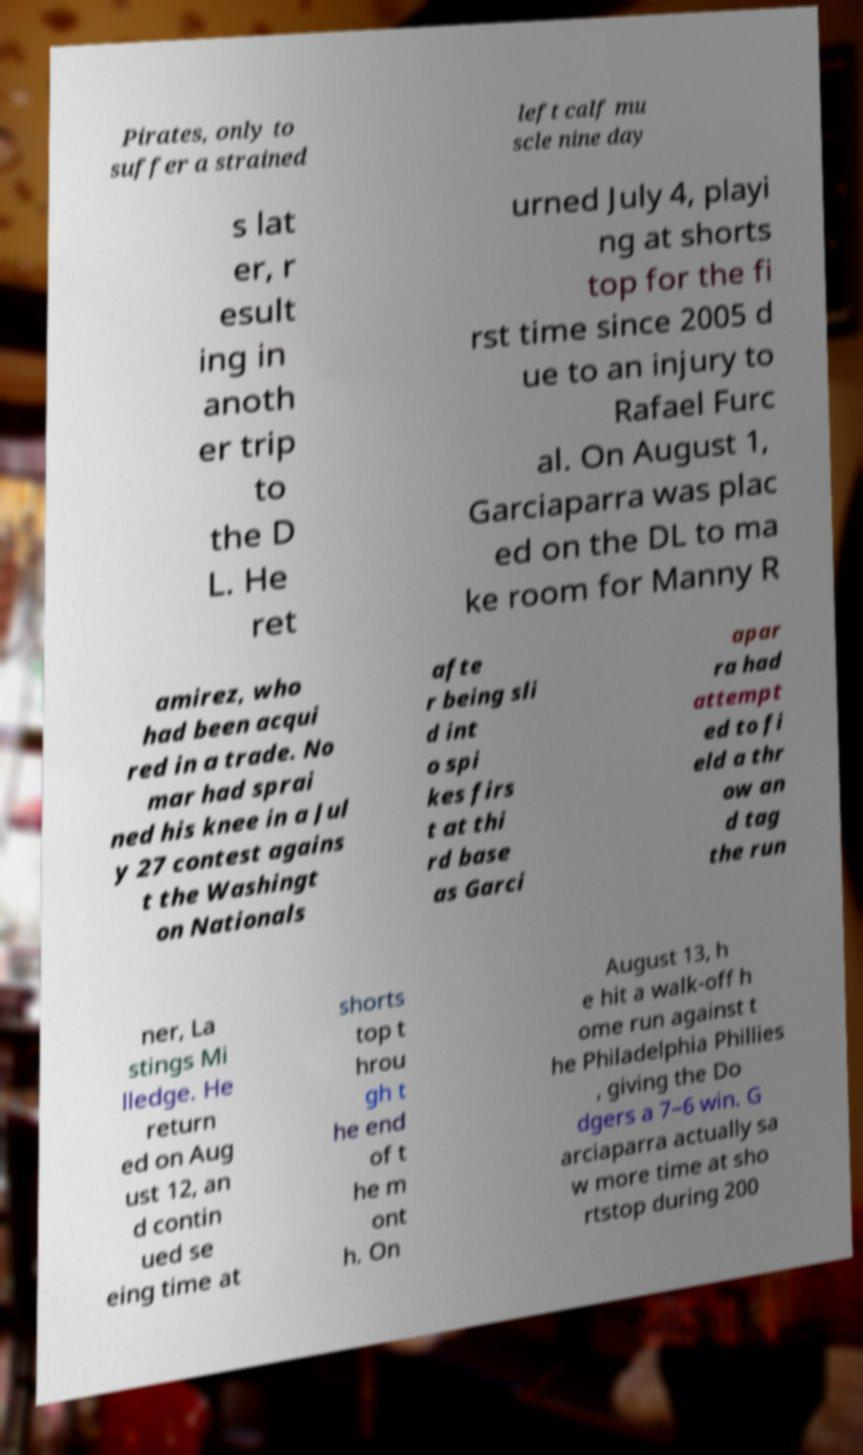Could you assist in decoding the text presented in this image and type it out clearly? Pirates, only to suffer a strained left calf mu scle nine day s lat er, r esult ing in anoth er trip to the D L. He ret urned July 4, playi ng at shorts top for the fi rst time since 2005 d ue to an injury to Rafael Furc al. On August 1, Garciaparra was plac ed on the DL to ma ke room for Manny R amirez, who had been acqui red in a trade. No mar had sprai ned his knee in a Jul y 27 contest agains t the Washingt on Nationals afte r being sli d int o spi kes firs t at thi rd base as Garci apar ra had attempt ed to fi eld a thr ow an d tag the run ner, La stings Mi lledge. He return ed on Aug ust 12, an d contin ued se eing time at shorts top t hrou gh t he end of t he m ont h. On August 13, h e hit a walk-off h ome run against t he Philadelphia Phillies , giving the Do dgers a 7–6 win. G arciaparra actually sa w more time at sho rtstop during 200 